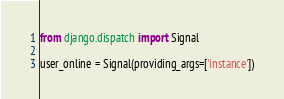<code> <loc_0><loc_0><loc_500><loc_500><_Python_>from django.dispatch import Signal

user_online = Signal(providing_args=['instance'])
</code> 